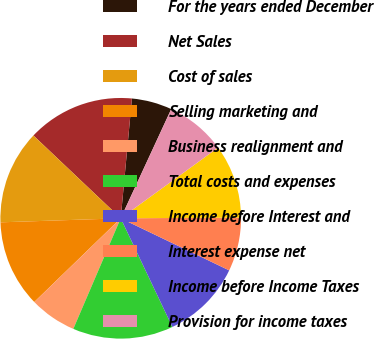Convert chart to OTSL. <chart><loc_0><loc_0><loc_500><loc_500><pie_chart><fcel>For the years ended December<fcel>Net Sales<fcel>Cost of sales<fcel>Selling marketing and<fcel>Business realignment and<fcel>Total costs and expenses<fcel>Income before Interest and<fcel>Interest expense net<fcel>Income before Income Taxes<fcel>Provision for income taxes<nl><fcel>5.41%<fcel>14.41%<fcel>12.61%<fcel>11.71%<fcel>6.31%<fcel>13.51%<fcel>10.81%<fcel>7.21%<fcel>9.91%<fcel>8.11%<nl></chart> 